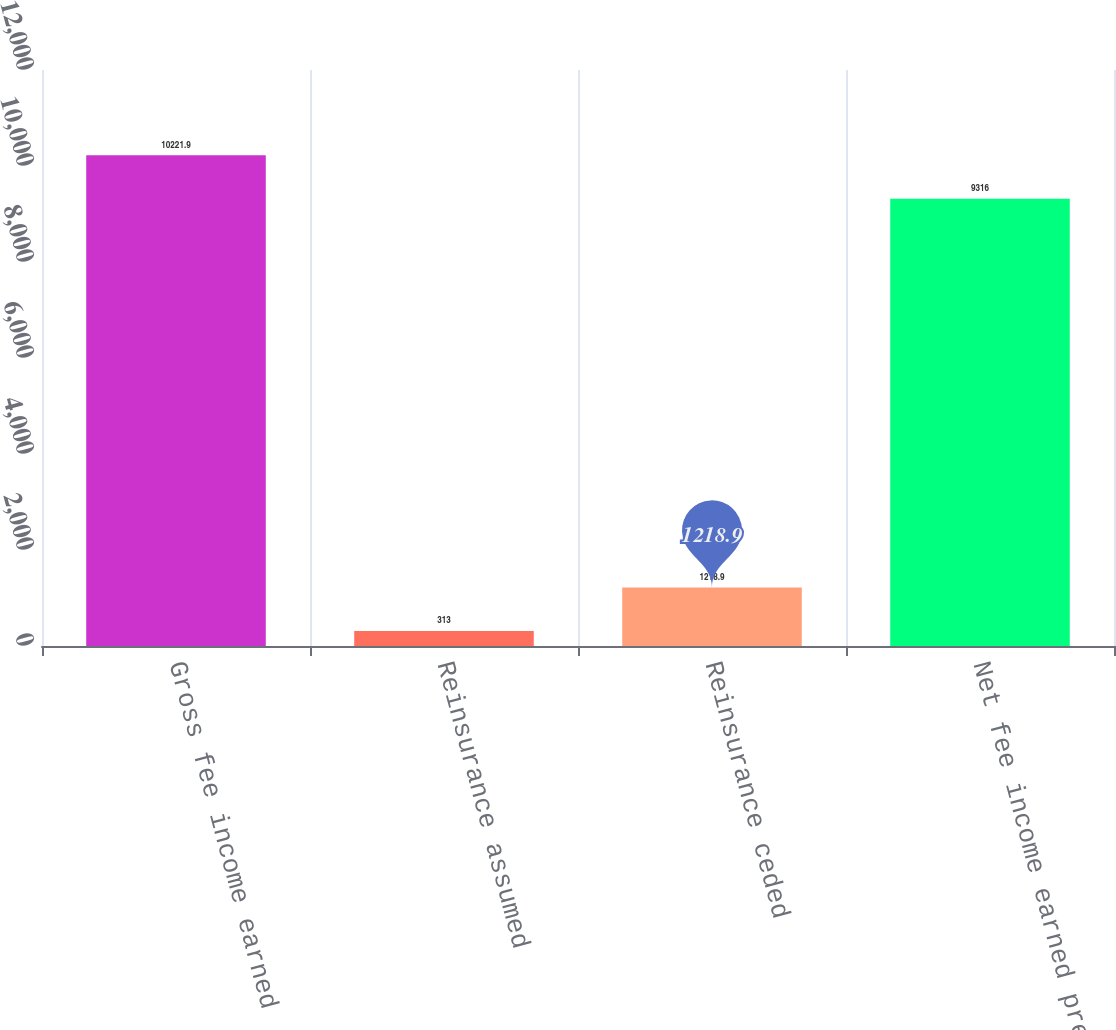Convert chart to OTSL. <chart><loc_0><loc_0><loc_500><loc_500><bar_chart><fcel>Gross fee income earned<fcel>Reinsurance assumed<fcel>Reinsurance ceded<fcel>Net fee income earned premiums<nl><fcel>10221.9<fcel>313<fcel>1218.9<fcel>9316<nl></chart> 